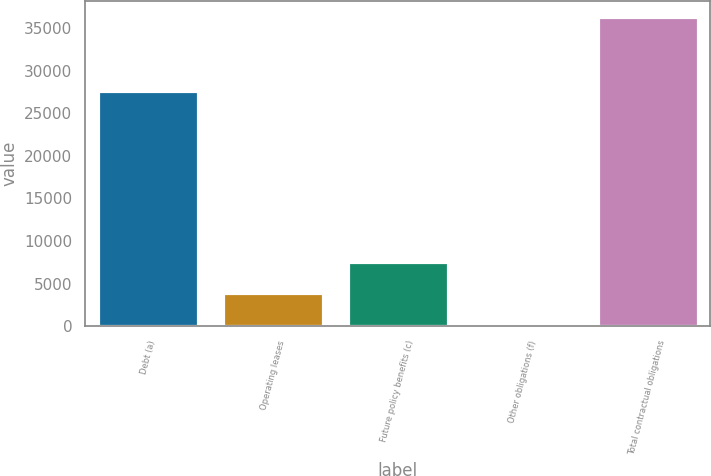Convert chart. <chart><loc_0><loc_0><loc_500><loc_500><bar_chart><fcel>Debt (a)<fcel>Operating leases<fcel>Future policy benefits (c)<fcel>Other obligations (f)<fcel>Total contractual obligations<nl><fcel>27652<fcel>3873.8<fcel>7479.6<fcel>268<fcel>36326<nl></chart> 